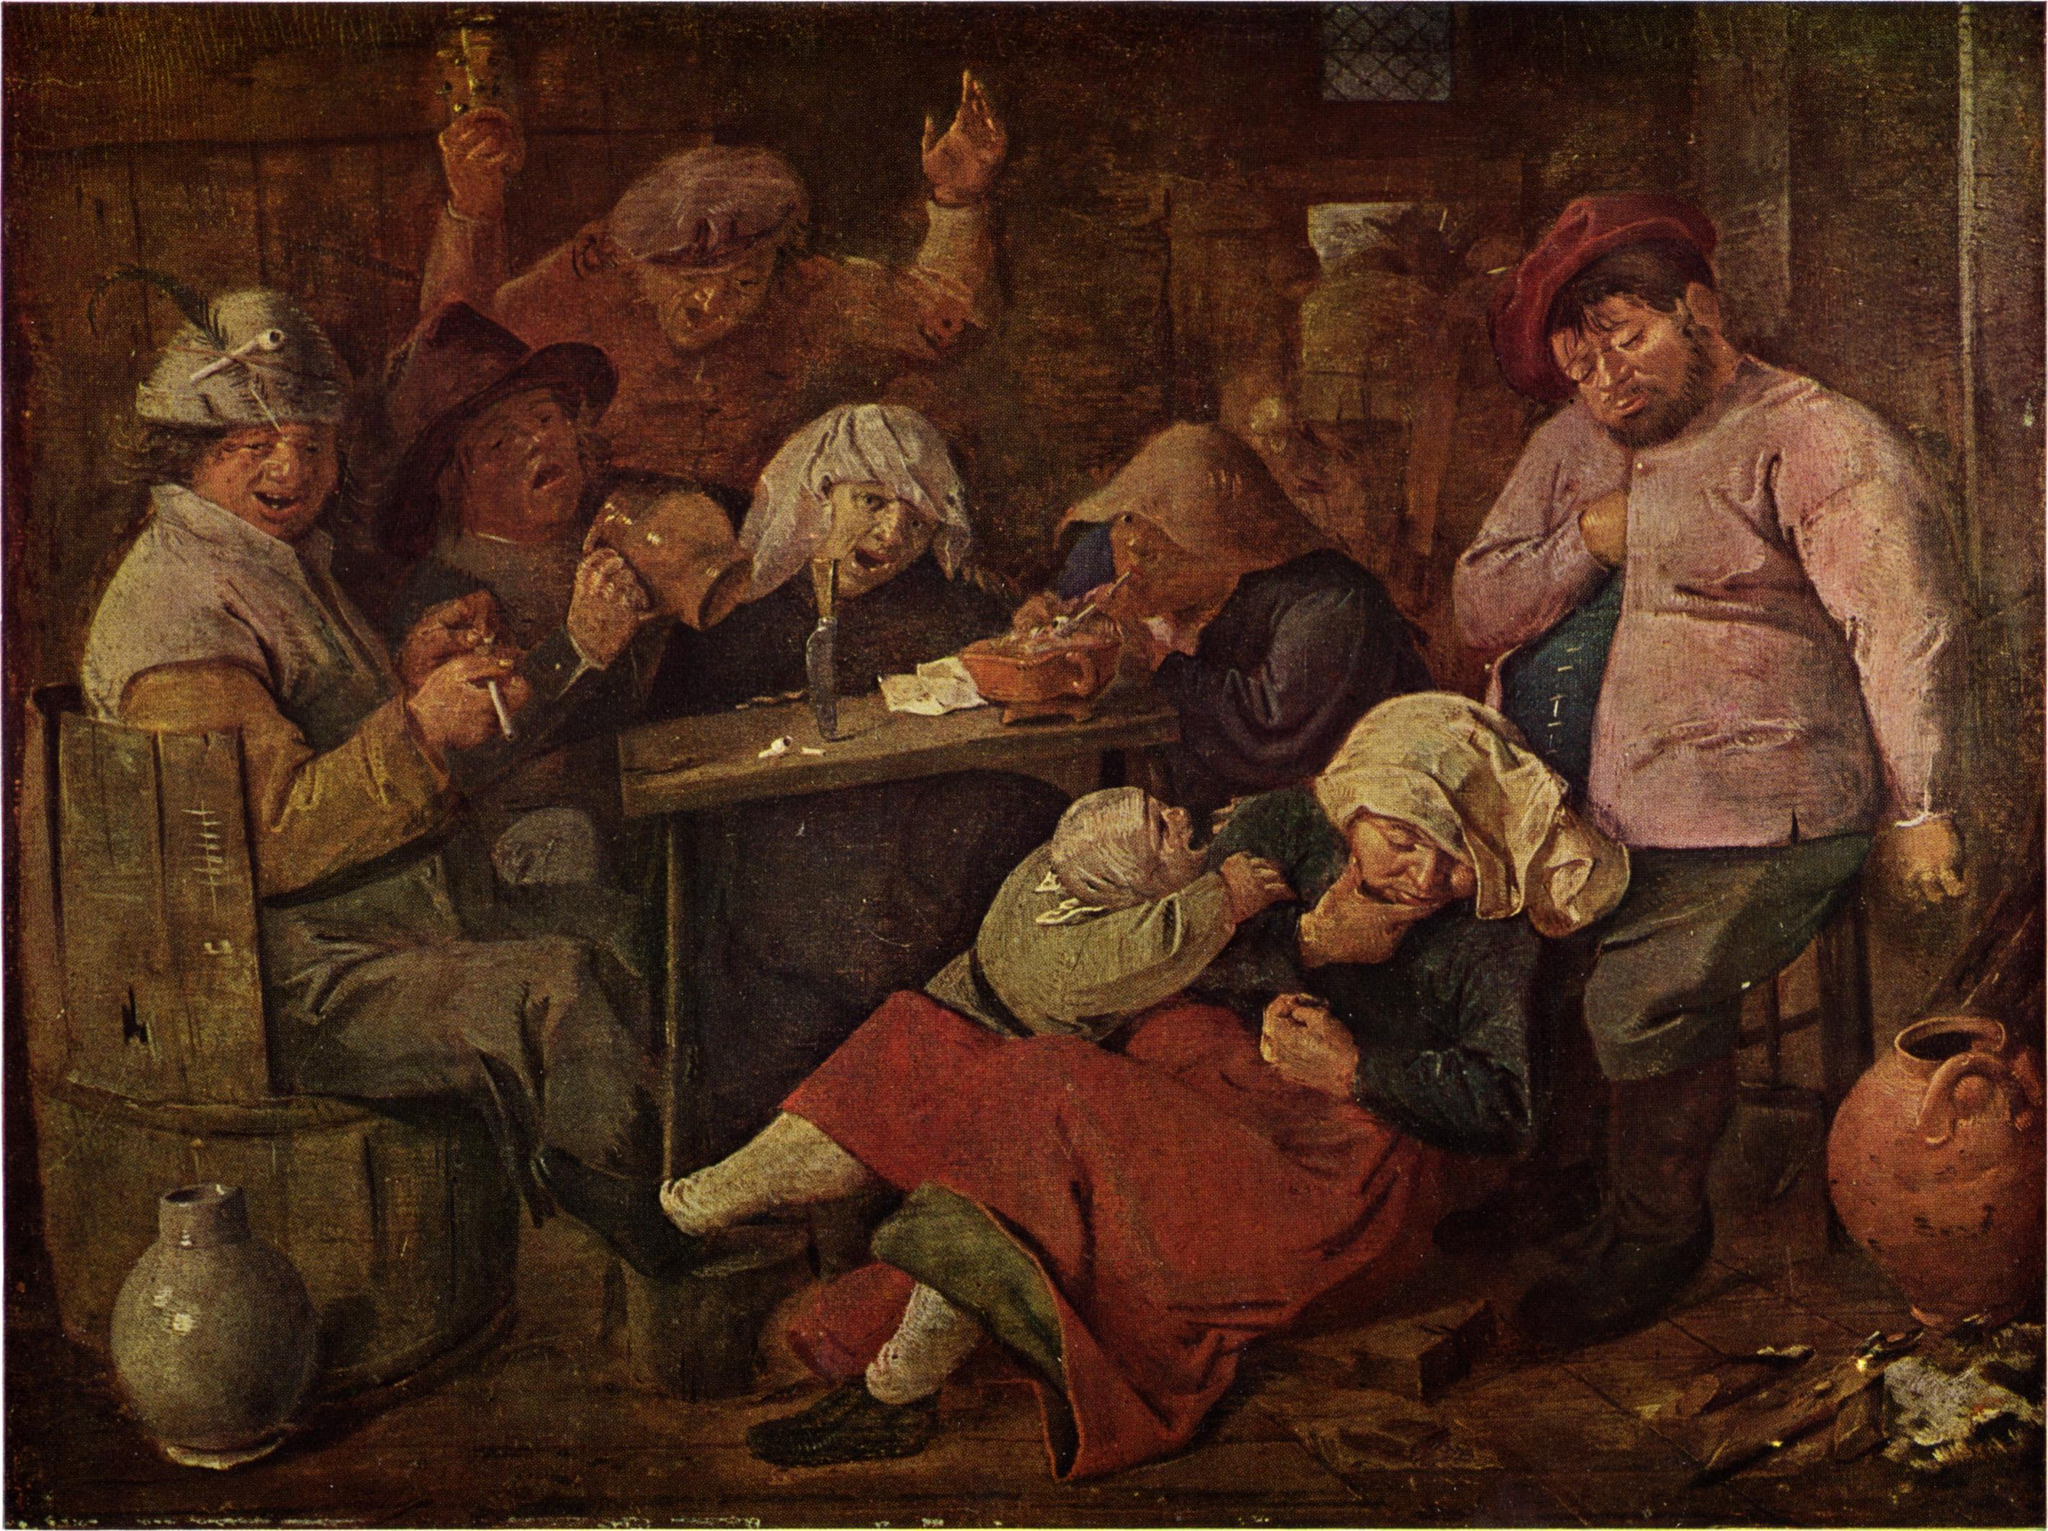What makes this painting an exemplary work of the Dutch Golden Age? This painting embodies the key characteristics of Dutch Golden Age art through its meticulous attention to detail, lifelike representation of everyday scenes, and expert use of light and shadow. The artist captures the essence of 17th-century Dutch life, focusing on the ordinary and portraying it with a rich authenticity that resonates with viewers. The warm, earthy palette, punctuated by vivid accents, brings vibrancy and depth to the scene. The interplay of light and shadow, particularly the illumination from a single candle, highlights the painter's skill in creating a dynamic, three-dimensional effect. The inclusion of various activities within the tavern—each figure immersed in drinking, smoking, playing cards—provides a glimpse into the diverse facets of social life during that era. This blend of technical prowess and cultural insight is what makes the painting a quintessential piece of the Dutch Golden Age.  Do you think the people in this painting are part of a family? Why or why not? While it's possible that some of the people in the painting are related, the scene primarily suggests a gathering of friends and acquaintances rather than an immediate family. The mix of individuals, their differing ages, and the casual, communal atmosphere of the tavern all hint at a social blend typical of a local meeting place. The painting captures a moment of shared leisure, reflecting the social dynamics of the time where taverns served as common grounds for community gatherings, transcending familial ties. The warm interactions and camaraderie seen here could denote close friendships that, much like family bonds, are essential parts of the social fabric. 